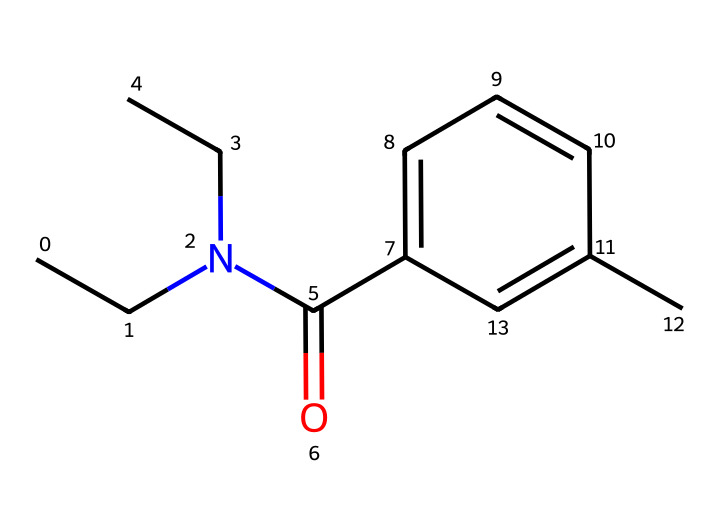What is the chemical name of the compound represented by this SMILES? The SMILES representation corresponds to N,N-Diethyl-m-toluamide, commonly known as DEET. By analyzing the structure, the presence of specific functional groups and the arrangement of atoms lead us to identify its name.
Answer: N,N-Diethyl-m-toluamide How many carbon atoms are in the molecule? By examining the SMILES structure, we can count the carbon atoms. The "CC" indicates two carbons for the diethyl part, and the ring structure "c1cccc(C)c1" adds five more carbons, totaling seven. Therefore, the molecule has a total of nine carbon atoms.
Answer: nine What functional group is present in this chemical? In the SMILES, we can identify a carbonyl group (C=O) attached to the amine group. This carbonyl group, along with the structure, indicates the molecule contains an amide functional group.
Answer: amide What is the total number of nitrogen atoms in this compound? The SMILES contains "N" at the start and represents the two ethyl groups bonded to it, indicating that there is one nitrogen atom present.
Answer: one Does this compound have any aromatic characteristics? The structure contains a benzene ring (denoted by "c") in its composition, confirming the presence of aromatic characteristics. Aromatic rings typically exhibit unique stability and reactivity patterns.
Answer: yes Would you classify this compound as a pesticide? DEET is primarily used as an insect repellent and is classified as a pesticide since it is often employed to repel insects that would otherwise be pests in outdoor activities.
Answer: yes 